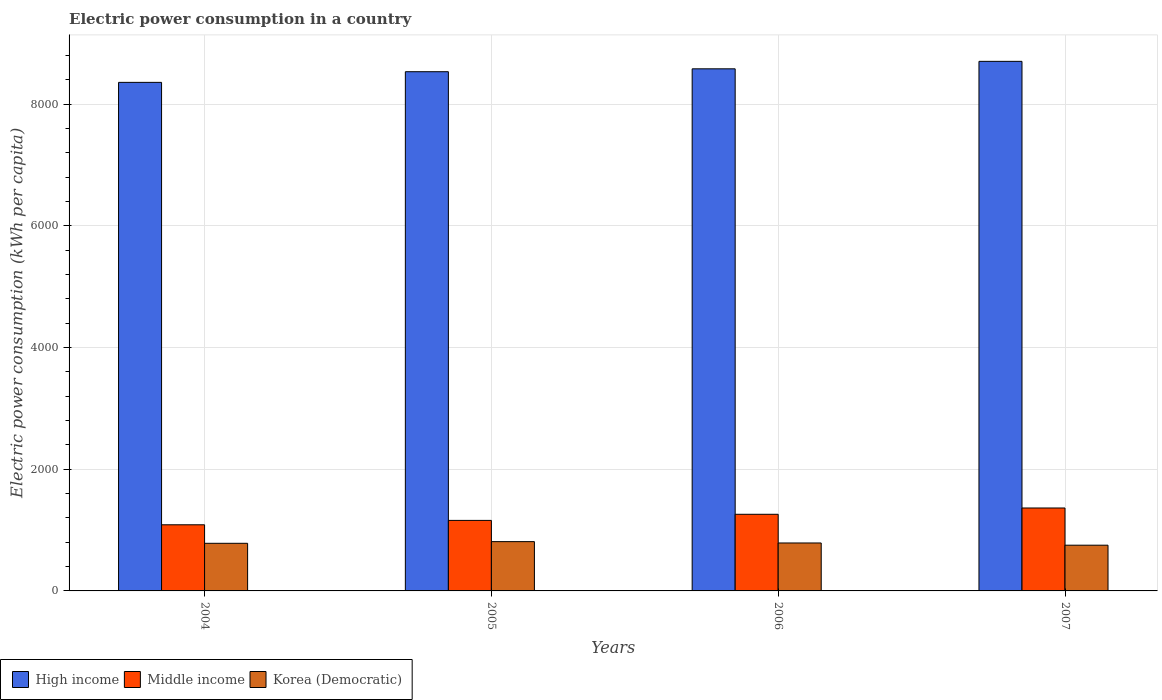How many groups of bars are there?
Give a very brief answer. 4. Are the number of bars per tick equal to the number of legend labels?
Your answer should be very brief. Yes. Are the number of bars on each tick of the X-axis equal?
Give a very brief answer. Yes. How many bars are there on the 3rd tick from the left?
Offer a very short reply. 3. What is the label of the 3rd group of bars from the left?
Provide a short and direct response. 2006. In how many cases, is the number of bars for a given year not equal to the number of legend labels?
Ensure brevity in your answer.  0. What is the electric power consumption in in High income in 2005?
Ensure brevity in your answer.  8533.71. Across all years, what is the maximum electric power consumption in in Korea (Democratic)?
Offer a terse response. 810.13. Across all years, what is the minimum electric power consumption in in Middle income?
Provide a short and direct response. 1086.87. In which year was the electric power consumption in in Middle income minimum?
Make the answer very short. 2004. What is the total electric power consumption in in High income in the graph?
Keep it short and to the point. 3.42e+04. What is the difference between the electric power consumption in in Korea (Democratic) in 2005 and that in 2006?
Provide a succinct answer. 22.06. What is the difference between the electric power consumption in in Middle income in 2005 and the electric power consumption in in Korea (Democratic) in 2004?
Your answer should be very brief. 376.39. What is the average electric power consumption in in High income per year?
Ensure brevity in your answer.  8544.31. In the year 2006, what is the difference between the electric power consumption in in Korea (Democratic) and electric power consumption in in High income?
Ensure brevity in your answer.  -7793.14. In how many years, is the electric power consumption in in High income greater than 1600 kWh per capita?
Your response must be concise. 4. What is the ratio of the electric power consumption in in High income in 2004 to that in 2007?
Your response must be concise. 0.96. What is the difference between the highest and the second highest electric power consumption in in Korea (Democratic)?
Ensure brevity in your answer.  22.06. What is the difference between the highest and the lowest electric power consumption in in High income?
Make the answer very short. 345.5. Is the sum of the electric power consumption in in High income in 2004 and 2005 greater than the maximum electric power consumption in in Middle income across all years?
Your response must be concise. Yes. What does the 1st bar from the left in 2004 represents?
Make the answer very short. High income. What does the 2nd bar from the right in 2004 represents?
Your answer should be very brief. Middle income. How many bars are there?
Give a very brief answer. 12. Are all the bars in the graph horizontal?
Give a very brief answer. No. How many years are there in the graph?
Keep it short and to the point. 4. What is the difference between two consecutive major ticks on the Y-axis?
Provide a succinct answer. 2000. Are the values on the major ticks of Y-axis written in scientific E-notation?
Your response must be concise. No. Does the graph contain any zero values?
Offer a terse response. No. Does the graph contain grids?
Offer a terse response. Yes. Where does the legend appear in the graph?
Provide a short and direct response. Bottom left. How many legend labels are there?
Provide a succinct answer. 3. How are the legend labels stacked?
Offer a very short reply. Horizontal. What is the title of the graph?
Ensure brevity in your answer.  Electric power consumption in a country. What is the label or title of the X-axis?
Your answer should be very brief. Years. What is the label or title of the Y-axis?
Your response must be concise. Electric power consumption (kWh per capita). What is the Electric power consumption (kWh per capita) of High income in 2004?
Offer a terse response. 8358.41. What is the Electric power consumption (kWh per capita) of Middle income in 2004?
Your answer should be compact. 1086.87. What is the Electric power consumption (kWh per capita) in Korea (Democratic) in 2004?
Your answer should be compact. 782.64. What is the Electric power consumption (kWh per capita) in High income in 2005?
Your answer should be compact. 8533.71. What is the Electric power consumption (kWh per capita) of Middle income in 2005?
Offer a terse response. 1159.02. What is the Electric power consumption (kWh per capita) in Korea (Democratic) in 2005?
Provide a short and direct response. 810.13. What is the Electric power consumption (kWh per capita) in High income in 2006?
Offer a terse response. 8581.21. What is the Electric power consumption (kWh per capita) of Middle income in 2006?
Keep it short and to the point. 1259.57. What is the Electric power consumption (kWh per capita) of Korea (Democratic) in 2006?
Your answer should be very brief. 788.07. What is the Electric power consumption (kWh per capita) in High income in 2007?
Your response must be concise. 8703.92. What is the Electric power consumption (kWh per capita) in Middle income in 2007?
Ensure brevity in your answer.  1363.07. What is the Electric power consumption (kWh per capita) in Korea (Democratic) in 2007?
Your response must be concise. 751.54. Across all years, what is the maximum Electric power consumption (kWh per capita) of High income?
Give a very brief answer. 8703.92. Across all years, what is the maximum Electric power consumption (kWh per capita) of Middle income?
Give a very brief answer. 1363.07. Across all years, what is the maximum Electric power consumption (kWh per capita) in Korea (Democratic)?
Offer a very short reply. 810.13. Across all years, what is the minimum Electric power consumption (kWh per capita) in High income?
Your answer should be compact. 8358.41. Across all years, what is the minimum Electric power consumption (kWh per capita) of Middle income?
Give a very brief answer. 1086.87. Across all years, what is the minimum Electric power consumption (kWh per capita) in Korea (Democratic)?
Keep it short and to the point. 751.54. What is the total Electric power consumption (kWh per capita) in High income in the graph?
Offer a very short reply. 3.42e+04. What is the total Electric power consumption (kWh per capita) of Middle income in the graph?
Your answer should be compact. 4868.53. What is the total Electric power consumption (kWh per capita) of Korea (Democratic) in the graph?
Ensure brevity in your answer.  3132.38. What is the difference between the Electric power consumption (kWh per capita) in High income in 2004 and that in 2005?
Ensure brevity in your answer.  -175.29. What is the difference between the Electric power consumption (kWh per capita) of Middle income in 2004 and that in 2005?
Your answer should be compact. -72.16. What is the difference between the Electric power consumption (kWh per capita) of Korea (Democratic) in 2004 and that in 2005?
Provide a succinct answer. -27.5. What is the difference between the Electric power consumption (kWh per capita) of High income in 2004 and that in 2006?
Ensure brevity in your answer.  -222.8. What is the difference between the Electric power consumption (kWh per capita) of Middle income in 2004 and that in 2006?
Provide a short and direct response. -172.7. What is the difference between the Electric power consumption (kWh per capita) in Korea (Democratic) in 2004 and that in 2006?
Provide a succinct answer. -5.43. What is the difference between the Electric power consumption (kWh per capita) of High income in 2004 and that in 2007?
Give a very brief answer. -345.5. What is the difference between the Electric power consumption (kWh per capita) of Middle income in 2004 and that in 2007?
Provide a succinct answer. -276.21. What is the difference between the Electric power consumption (kWh per capita) in Korea (Democratic) in 2004 and that in 2007?
Provide a short and direct response. 31.1. What is the difference between the Electric power consumption (kWh per capita) of High income in 2005 and that in 2006?
Offer a very short reply. -47.51. What is the difference between the Electric power consumption (kWh per capita) of Middle income in 2005 and that in 2006?
Your answer should be very brief. -100.54. What is the difference between the Electric power consumption (kWh per capita) in Korea (Democratic) in 2005 and that in 2006?
Give a very brief answer. 22.06. What is the difference between the Electric power consumption (kWh per capita) in High income in 2005 and that in 2007?
Your response must be concise. -170.21. What is the difference between the Electric power consumption (kWh per capita) in Middle income in 2005 and that in 2007?
Your answer should be compact. -204.05. What is the difference between the Electric power consumption (kWh per capita) of Korea (Democratic) in 2005 and that in 2007?
Ensure brevity in your answer.  58.6. What is the difference between the Electric power consumption (kWh per capita) in High income in 2006 and that in 2007?
Ensure brevity in your answer.  -122.7. What is the difference between the Electric power consumption (kWh per capita) of Middle income in 2006 and that in 2007?
Keep it short and to the point. -103.51. What is the difference between the Electric power consumption (kWh per capita) of Korea (Democratic) in 2006 and that in 2007?
Make the answer very short. 36.54. What is the difference between the Electric power consumption (kWh per capita) of High income in 2004 and the Electric power consumption (kWh per capita) of Middle income in 2005?
Make the answer very short. 7199.39. What is the difference between the Electric power consumption (kWh per capita) in High income in 2004 and the Electric power consumption (kWh per capita) in Korea (Democratic) in 2005?
Offer a very short reply. 7548.28. What is the difference between the Electric power consumption (kWh per capita) of Middle income in 2004 and the Electric power consumption (kWh per capita) of Korea (Democratic) in 2005?
Provide a short and direct response. 276.73. What is the difference between the Electric power consumption (kWh per capita) of High income in 2004 and the Electric power consumption (kWh per capita) of Middle income in 2006?
Offer a very short reply. 7098.85. What is the difference between the Electric power consumption (kWh per capita) of High income in 2004 and the Electric power consumption (kWh per capita) of Korea (Democratic) in 2006?
Provide a short and direct response. 7570.34. What is the difference between the Electric power consumption (kWh per capita) of Middle income in 2004 and the Electric power consumption (kWh per capita) of Korea (Democratic) in 2006?
Give a very brief answer. 298.8. What is the difference between the Electric power consumption (kWh per capita) of High income in 2004 and the Electric power consumption (kWh per capita) of Middle income in 2007?
Provide a short and direct response. 6995.34. What is the difference between the Electric power consumption (kWh per capita) in High income in 2004 and the Electric power consumption (kWh per capita) in Korea (Democratic) in 2007?
Give a very brief answer. 7606.88. What is the difference between the Electric power consumption (kWh per capita) in Middle income in 2004 and the Electric power consumption (kWh per capita) in Korea (Democratic) in 2007?
Ensure brevity in your answer.  335.33. What is the difference between the Electric power consumption (kWh per capita) in High income in 2005 and the Electric power consumption (kWh per capita) in Middle income in 2006?
Ensure brevity in your answer.  7274.14. What is the difference between the Electric power consumption (kWh per capita) of High income in 2005 and the Electric power consumption (kWh per capita) of Korea (Democratic) in 2006?
Your answer should be very brief. 7745.63. What is the difference between the Electric power consumption (kWh per capita) of Middle income in 2005 and the Electric power consumption (kWh per capita) of Korea (Democratic) in 2006?
Offer a very short reply. 370.95. What is the difference between the Electric power consumption (kWh per capita) in High income in 2005 and the Electric power consumption (kWh per capita) in Middle income in 2007?
Provide a short and direct response. 7170.63. What is the difference between the Electric power consumption (kWh per capita) of High income in 2005 and the Electric power consumption (kWh per capita) of Korea (Democratic) in 2007?
Make the answer very short. 7782.17. What is the difference between the Electric power consumption (kWh per capita) of Middle income in 2005 and the Electric power consumption (kWh per capita) of Korea (Democratic) in 2007?
Provide a short and direct response. 407.49. What is the difference between the Electric power consumption (kWh per capita) in High income in 2006 and the Electric power consumption (kWh per capita) in Middle income in 2007?
Offer a very short reply. 7218.14. What is the difference between the Electric power consumption (kWh per capita) in High income in 2006 and the Electric power consumption (kWh per capita) in Korea (Democratic) in 2007?
Give a very brief answer. 7829.68. What is the difference between the Electric power consumption (kWh per capita) in Middle income in 2006 and the Electric power consumption (kWh per capita) in Korea (Democratic) in 2007?
Make the answer very short. 508.03. What is the average Electric power consumption (kWh per capita) in High income per year?
Keep it short and to the point. 8544.31. What is the average Electric power consumption (kWh per capita) in Middle income per year?
Provide a short and direct response. 1217.13. What is the average Electric power consumption (kWh per capita) of Korea (Democratic) per year?
Your answer should be very brief. 783.1. In the year 2004, what is the difference between the Electric power consumption (kWh per capita) of High income and Electric power consumption (kWh per capita) of Middle income?
Give a very brief answer. 7271.55. In the year 2004, what is the difference between the Electric power consumption (kWh per capita) of High income and Electric power consumption (kWh per capita) of Korea (Democratic)?
Give a very brief answer. 7575.78. In the year 2004, what is the difference between the Electric power consumption (kWh per capita) in Middle income and Electric power consumption (kWh per capita) in Korea (Democratic)?
Your response must be concise. 304.23. In the year 2005, what is the difference between the Electric power consumption (kWh per capita) in High income and Electric power consumption (kWh per capita) in Middle income?
Your answer should be very brief. 7374.68. In the year 2005, what is the difference between the Electric power consumption (kWh per capita) in High income and Electric power consumption (kWh per capita) in Korea (Democratic)?
Keep it short and to the point. 7723.57. In the year 2005, what is the difference between the Electric power consumption (kWh per capita) in Middle income and Electric power consumption (kWh per capita) in Korea (Democratic)?
Provide a short and direct response. 348.89. In the year 2006, what is the difference between the Electric power consumption (kWh per capita) in High income and Electric power consumption (kWh per capita) in Middle income?
Your answer should be very brief. 7321.65. In the year 2006, what is the difference between the Electric power consumption (kWh per capita) in High income and Electric power consumption (kWh per capita) in Korea (Democratic)?
Ensure brevity in your answer.  7793.14. In the year 2006, what is the difference between the Electric power consumption (kWh per capita) of Middle income and Electric power consumption (kWh per capita) of Korea (Democratic)?
Give a very brief answer. 471.5. In the year 2007, what is the difference between the Electric power consumption (kWh per capita) of High income and Electric power consumption (kWh per capita) of Middle income?
Give a very brief answer. 7340.84. In the year 2007, what is the difference between the Electric power consumption (kWh per capita) in High income and Electric power consumption (kWh per capita) in Korea (Democratic)?
Provide a short and direct response. 7952.38. In the year 2007, what is the difference between the Electric power consumption (kWh per capita) of Middle income and Electric power consumption (kWh per capita) of Korea (Democratic)?
Your answer should be very brief. 611.54. What is the ratio of the Electric power consumption (kWh per capita) of High income in 2004 to that in 2005?
Your answer should be very brief. 0.98. What is the ratio of the Electric power consumption (kWh per capita) of Middle income in 2004 to that in 2005?
Ensure brevity in your answer.  0.94. What is the ratio of the Electric power consumption (kWh per capita) in Korea (Democratic) in 2004 to that in 2005?
Provide a succinct answer. 0.97. What is the ratio of the Electric power consumption (kWh per capita) in Middle income in 2004 to that in 2006?
Offer a terse response. 0.86. What is the ratio of the Electric power consumption (kWh per capita) in Korea (Democratic) in 2004 to that in 2006?
Ensure brevity in your answer.  0.99. What is the ratio of the Electric power consumption (kWh per capita) of High income in 2004 to that in 2007?
Ensure brevity in your answer.  0.96. What is the ratio of the Electric power consumption (kWh per capita) in Middle income in 2004 to that in 2007?
Your answer should be very brief. 0.8. What is the ratio of the Electric power consumption (kWh per capita) in Korea (Democratic) in 2004 to that in 2007?
Provide a succinct answer. 1.04. What is the ratio of the Electric power consumption (kWh per capita) in High income in 2005 to that in 2006?
Give a very brief answer. 0.99. What is the ratio of the Electric power consumption (kWh per capita) in Middle income in 2005 to that in 2006?
Your answer should be very brief. 0.92. What is the ratio of the Electric power consumption (kWh per capita) of Korea (Democratic) in 2005 to that in 2006?
Keep it short and to the point. 1.03. What is the ratio of the Electric power consumption (kWh per capita) of High income in 2005 to that in 2007?
Your answer should be very brief. 0.98. What is the ratio of the Electric power consumption (kWh per capita) of Middle income in 2005 to that in 2007?
Give a very brief answer. 0.85. What is the ratio of the Electric power consumption (kWh per capita) of Korea (Democratic) in 2005 to that in 2007?
Your answer should be compact. 1.08. What is the ratio of the Electric power consumption (kWh per capita) in High income in 2006 to that in 2007?
Make the answer very short. 0.99. What is the ratio of the Electric power consumption (kWh per capita) in Middle income in 2006 to that in 2007?
Your answer should be very brief. 0.92. What is the ratio of the Electric power consumption (kWh per capita) in Korea (Democratic) in 2006 to that in 2007?
Offer a terse response. 1.05. What is the difference between the highest and the second highest Electric power consumption (kWh per capita) in High income?
Make the answer very short. 122.7. What is the difference between the highest and the second highest Electric power consumption (kWh per capita) of Middle income?
Provide a succinct answer. 103.51. What is the difference between the highest and the second highest Electric power consumption (kWh per capita) of Korea (Democratic)?
Your answer should be compact. 22.06. What is the difference between the highest and the lowest Electric power consumption (kWh per capita) of High income?
Make the answer very short. 345.5. What is the difference between the highest and the lowest Electric power consumption (kWh per capita) in Middle income?
Make the answer very short. 276.21. What is the difference between the highest and the lowest Electric power consumption (kWh per capita) in Korea (Democratic)?
Offer a very short reply. 58.6. 